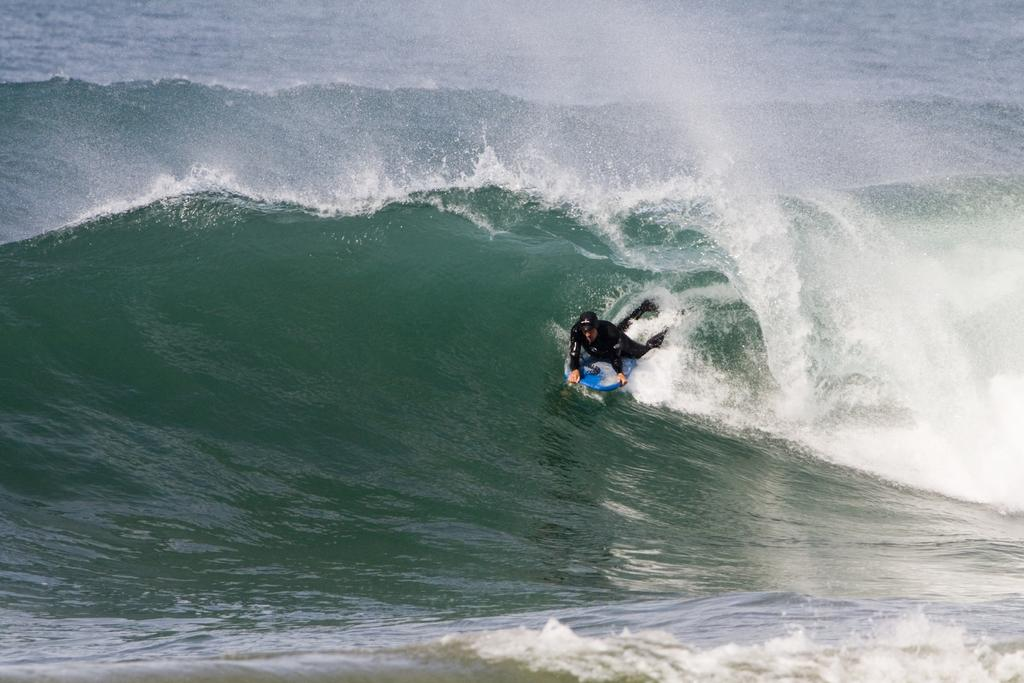Who is the main subject in the image? There is a man in the image. What is the man wearing in the image? The man is wearing a swimming suit. What is the man doing in the image? The man is lying on a surfboard and surfing on the water. What type of prose is the man reading while surfing in the image? There is no prose present in the image; the man is focused on surfing. What color is the underwear the man is wearing under his swimming suit in the image? The image does not show the man wearing any underwear, only a swimming suit. 